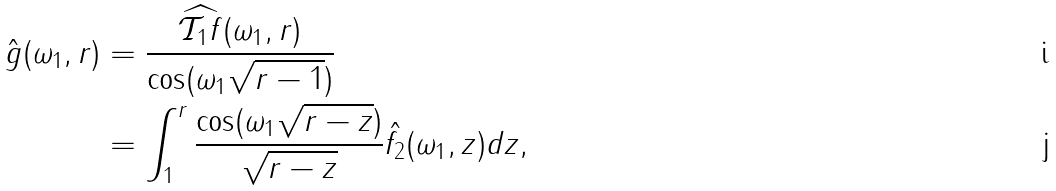Convert formula to latex. <formula><loc_0><loc_0><loc_500><loc_500>\hat { g } ( \omega _ { 1 } , r ) & = \frac { \widehat { \mathcal { T } _ { 1 } f } ( \omega _ { 1 } , r ) } { \cos ( \omega _ { 1 } \sqrt { r - 1 } ) } \\ & = \int _ { 1 } ^ { r } \frac { \cos ( \omega _ { 1 } \sqrt { r - z } ) } { \sqrt { r - z } } \hat { f _ { 2 } } ( \omega _ { 1 } , z ) d z ,</formula> 